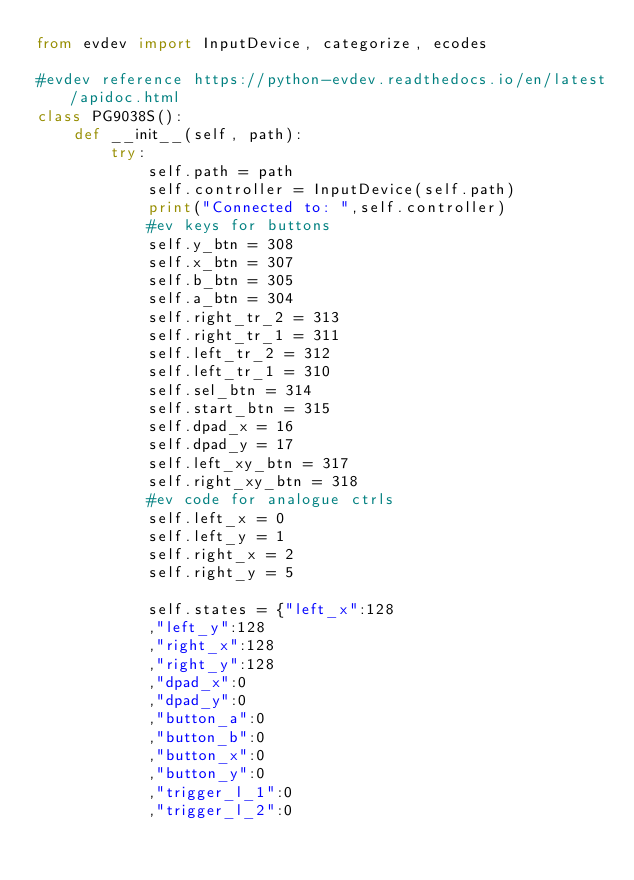Convert code to text. <code><loc_0><loc_0><loc_500><loc_500><_Python_>from evdev import InputDevice, categorize, ecodes

#evdev reference https://python-evdev.readthedocs.io/en/latest/apidoc.html
class PG9038S():
    def __init__(self, path):
        try:
            self.path = path
            self.controller = InputDevice(self.path)
            print("Connected to: ",self.controller)
            #ev keys for buttons
            self.y_btn = 308
            self.x_btn = 307
            self.b_btn = 305
            self.a_btn = 304
            self.right_tr_2 = 313
            self.right_tr_1 = 311
            self.left_tr_2 = 312
            self.left_tr_1 = 310
            self.sel_btn = 314
            self.start_btn = 315
            self.dpad_x = 16
            self.dpad_y = 17
            self.left_xy_btn = 317
            self.right_xy_btn = 318
            #ev code for analogue ctrls
            self.left_x = 0
            self.left_y = 1
            self.right_x = 2
            self.right_y = 5

            self.states = {"left_x":128
            ,"left_y":128
            ,"right_x":128
            ,"right_y":128
            ,"dpad_x":0
            ,"dpad_y":0
            ,"button_a":0
            ,"button_b":0
            ,"button_x":0
            ,"button_y":0
            ,"trigger_l_1":0
            ,"trigger_l_2":0</code> 